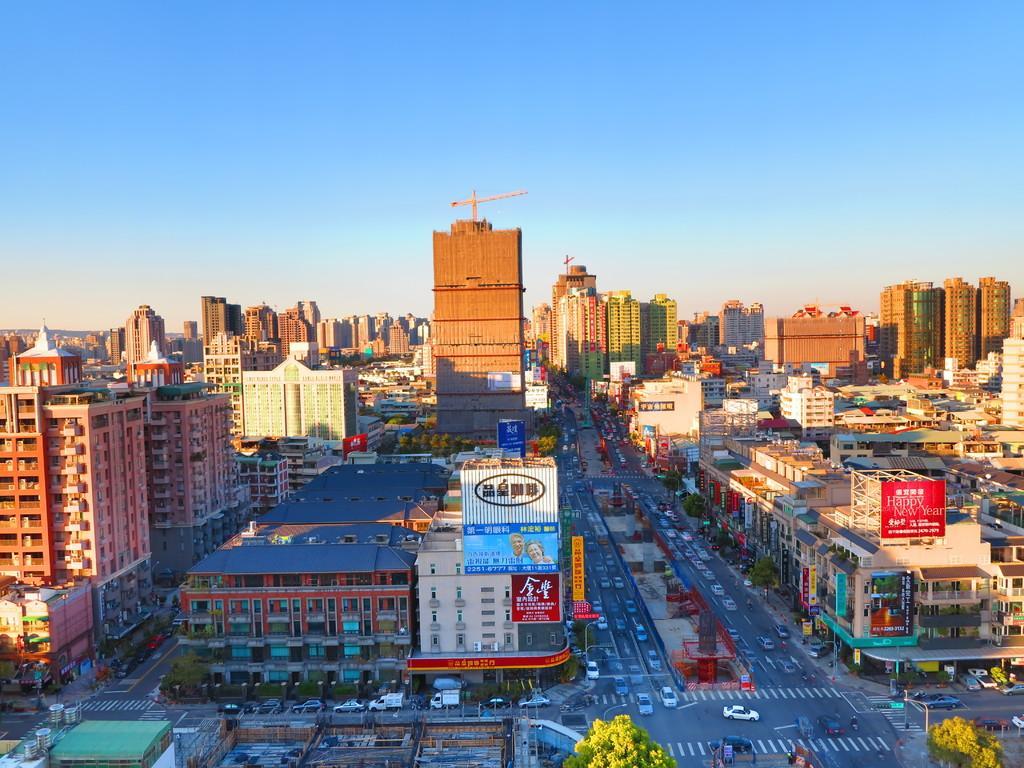In one or two sentences, can you explain what this image depicts? Bottom of the image there are some buildings and trees and poles and there are some vehicles on the road. Top of the image there are some clouds and sky. 